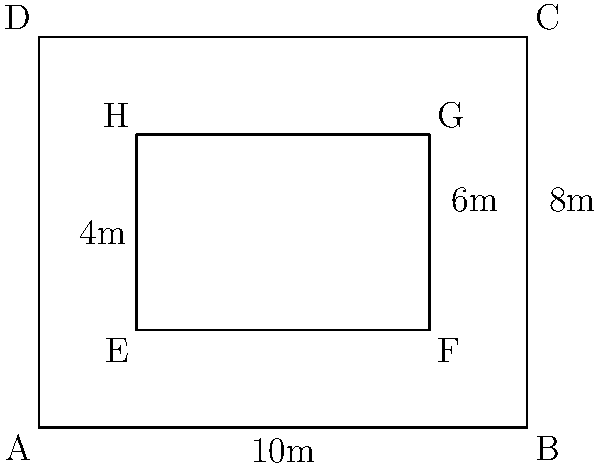You're designing a rectangular composting area for your sustainable garden. The outer dimensions of the area are 10m by 8m. Inside this area, you want to create a smaller rectangular composting bin, leaving a 2m wide path around all sides for easy access. What is the maximum area (in square meters) that the inner composting bin can occupy? Let's approach this step-by-step:

1) The outer rectangle has dimensions 10m x 8m.

2) We need to leave a 2m wide path on all sides. This means:
   - The width of the inner rectangle will be 2m less on each side: 10m - 2m - 2m = 6m
   - The height of the inner rectangle will be 2m less on top and bottom: 8m - 2m - 2m = 4m

3) Now we can calculate the area of the inner rectangle:
   $$ \text{Area} = \text{width} \times \text{height} $$
   $$ \text{Area} = 6\text{m} \times 4\text{m} = 24\text{m}^2 $$

Therefore, the maximum area that the inner composting bin can occupy is 24 square meters.
Answer: 24 m² 